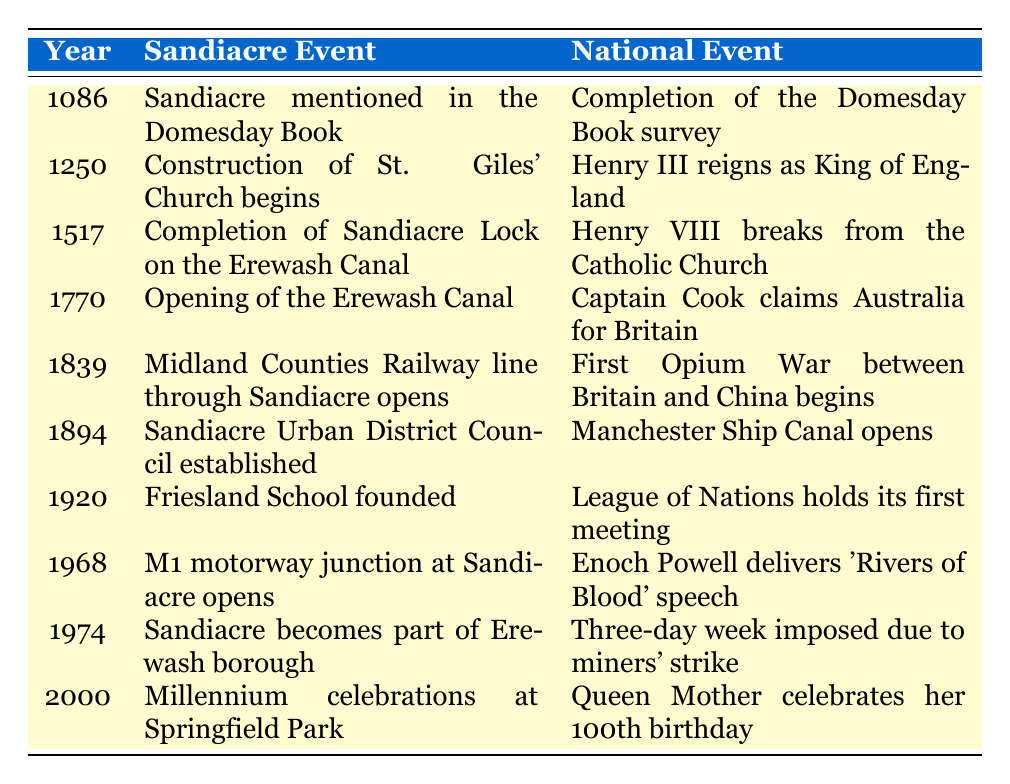What significant local event occurred in 1770? According to the table, the significant local event in 1770 was the opening of the Erewash Canal.
Answer: Opening of the Erewash Canal Which year did Sandiacre become part of Erewash borough? The table indicates that Sandiacre became part of the Erewash borough in 1974.
Answer: 1974 Was the construction of St. Giles' Church mentioned alongside a national event in 1250? Yes, the table shows that in 1250, the construction of St. Giles' Church began concurrently with Henry III reigning as King of England.
Answer: Yes What is the difference in years between the opening of the Erewash Canal and the establishment of the Sandiacre Urban District Council? To find the difference, subtract the year of the Erewash Canal opening (1770) from the year the Urban District Council was established (1894): 1894 - 1770 = 124 years.
Answer: 124 years In which year did Sandiacre's Millennium celebrations occur, and what national event coincided with it? The table shows that the Millennium celebrations at Springfield Park took place in 2000, coinciding with the Queen Mother celebrating her 100th birthday.
Answer: 2000; Queen Mother celebrates her 100th birthday What was the last event listed for Sandiacre in the timeline? The last event listed in the table for Sandiacre is the Millennium celebrations at Springfield Park in the year 2000.
Answer: Millennium celebrations at Springfield Park Did the opening of the Midland Counties Railway line through Sandiacre coincide with any conflict on a national level? Yes, according to the table, the opening of the railway line in 1839 coincided with the beginning of the First Opium War between Britain and China.
Answer: Yes Which two events were both established in 1920? The table indicates that in 1920, Friesland School was founded and the League of Nations held its first meeting.
Answer: Friesland School founded; League of Nations holds its first meeting 